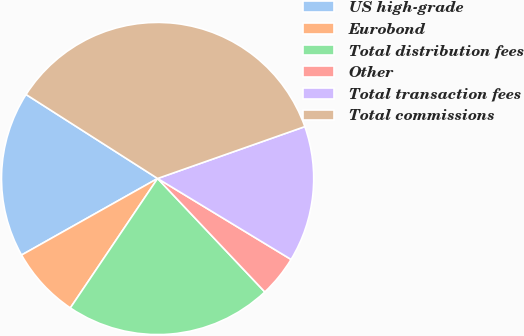Convert chart. <chart><loc_0><loc_0><loc_500><loc_500><pie_chart><fcel>US high-grade<fcel>Eurobond<fcel>Total distribution fees<fcel>Other<fcel>Total transaction fees<fcel>Total commissions<nl><fcel>17.2%<fcel>7.4%<fcel>21.49%<fcel>4.27%<fcel>14.07%<fcel>35.56%<nl></chart> 